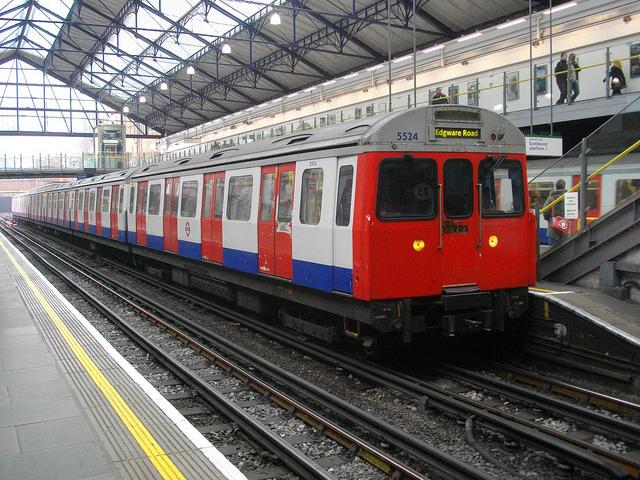Do you see a track?
Be succinct. Yes. What three colors is this train?
Write a very short answer. Red, white and blue. Where are the people?
Concise answer only. On train. 